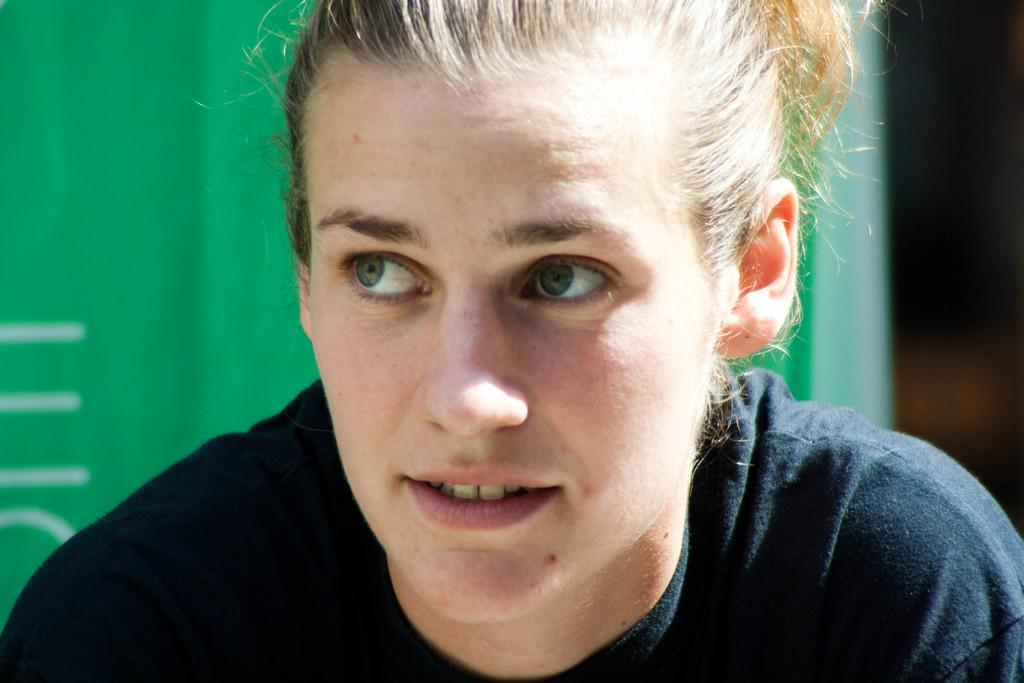Who is present in the image? There is a woman in the image. What can be seen in the background of the image? The background of the image is green. How many screws can be seen on the woman's clothing in the image? There are no screws visible on the woman's clothing in the image. What type of bears are present in the image? There are no bears present in the image. 